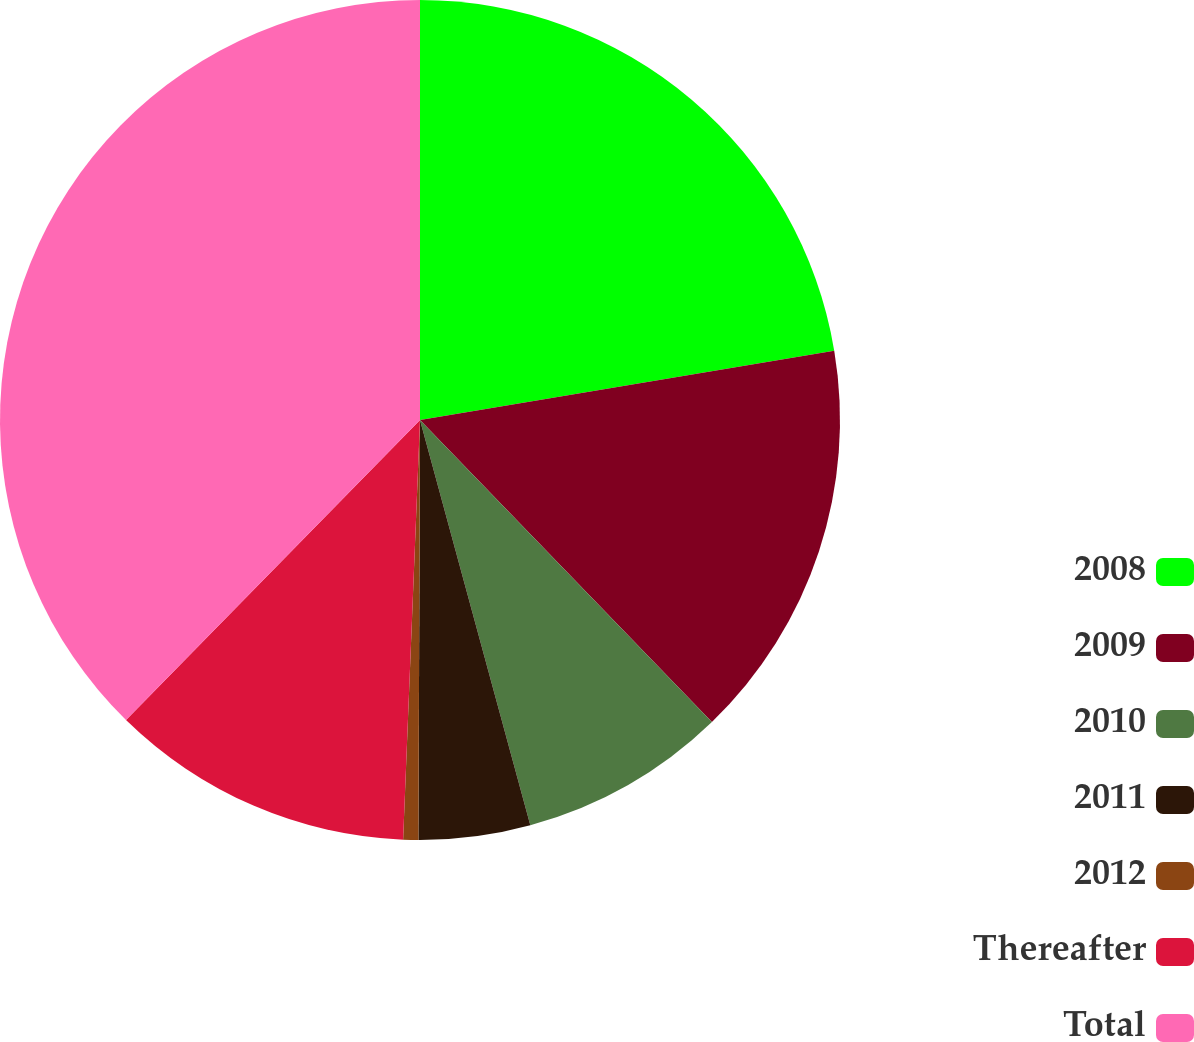Convert chart. <chart><loc_0><loc_0><loc_500><loc_500><pie_chart><fcel>2008<fcel>2009<fcel>2010<fcel>2011<fcel>2012<fcel>Thereafter<fcel>Total<nl><fcel>22.36%<fcel>15.41%<fcel>8.0%<fcel>4.29%<fcel>0.58%<fcel>11.7%<fcel>37.66%<nl></chart> 